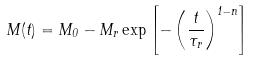Convert formula to latex. <formula><loc_0><loc_0><loc_500><loc_500>M ( t ) = M _ { 0 } - M _ { r } \exp \left [ - \left ( \frac { t } { \tau _ { r } } \right ) ^ { 1 - n } \right ]</formula> 